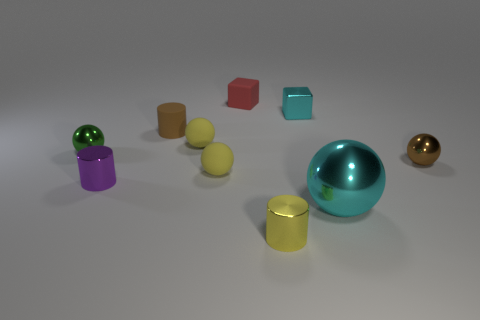Subtract 2 balls. How many balls are left? 3 Subtract all green metallic balls. How many balls are left? 4 Subtract all brown balls. How many balls are left? 4 Subtract all purple balls. Subtract all red blocks. How many balls are left? 5 Subtract all cylinders. How many objects are left? 7 Subtract 1 brown cylinders. How many objects are left? 9 Subtract all small yellow metallic cubes. Subtract all small yellow balls. How many objects are left? 8 Add 9 red cubes. How many red cubes are left? 10 Add 2 small yellow metal objects. How many small yellow metal objects exist? 3 